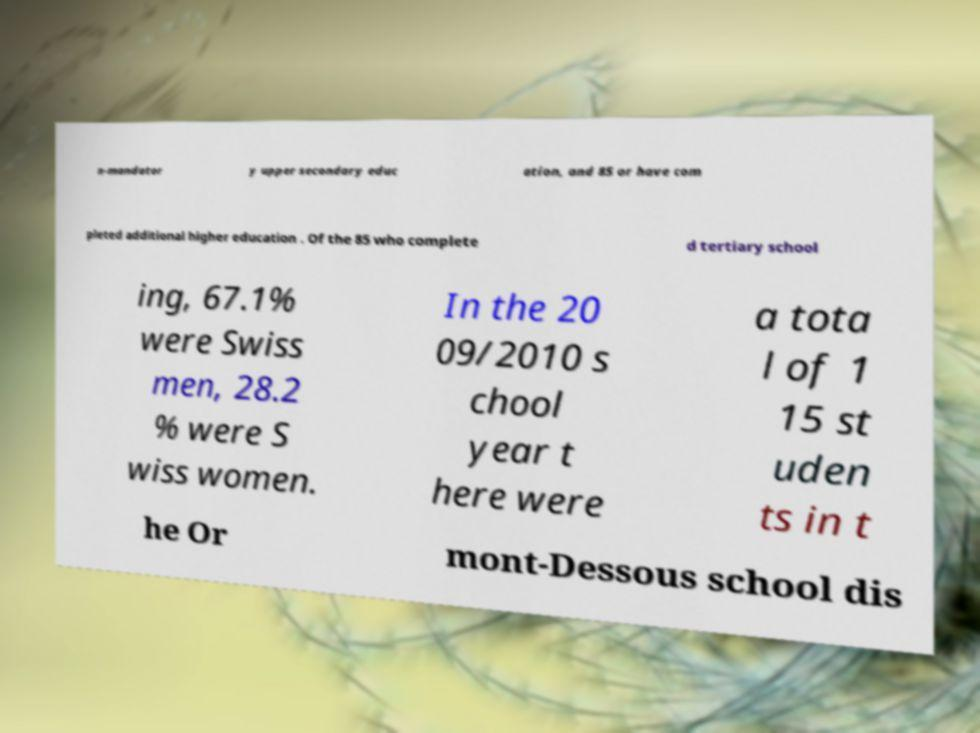What messages or text are displayed in this image? I need them in a readable, typed format. n-mandator y upper secondary educ ation, and 85 or have com pleted additional higher education . Of the 85 who complete d tertiary school ing, 67.1% were Swiss men, 28.2 % were S wiss women. In the 20 09/2010 s chool year t here were a tota l of 1 15 st uden ts in t he Or mont-Dessous school dis 